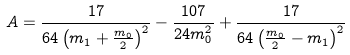Convert formula to latex. <formula><loc_0><loc_0><loc_500><loc_500>A = \frac { 1 7 } { 6 4 \left ( m _ { 1 } + \frac { m _ { 0 } } { 2 } \right ) ^ { 2 } } - \frac { 1 0 7 } { 2 4 m _ { 0 } ^ { 2 } } + \frac { 1 7 } { 6 4 \left ( \frac { m _ { 0 } } { 2 } - m _ { 1 } \right ) ^ { 2 } }</formula> 